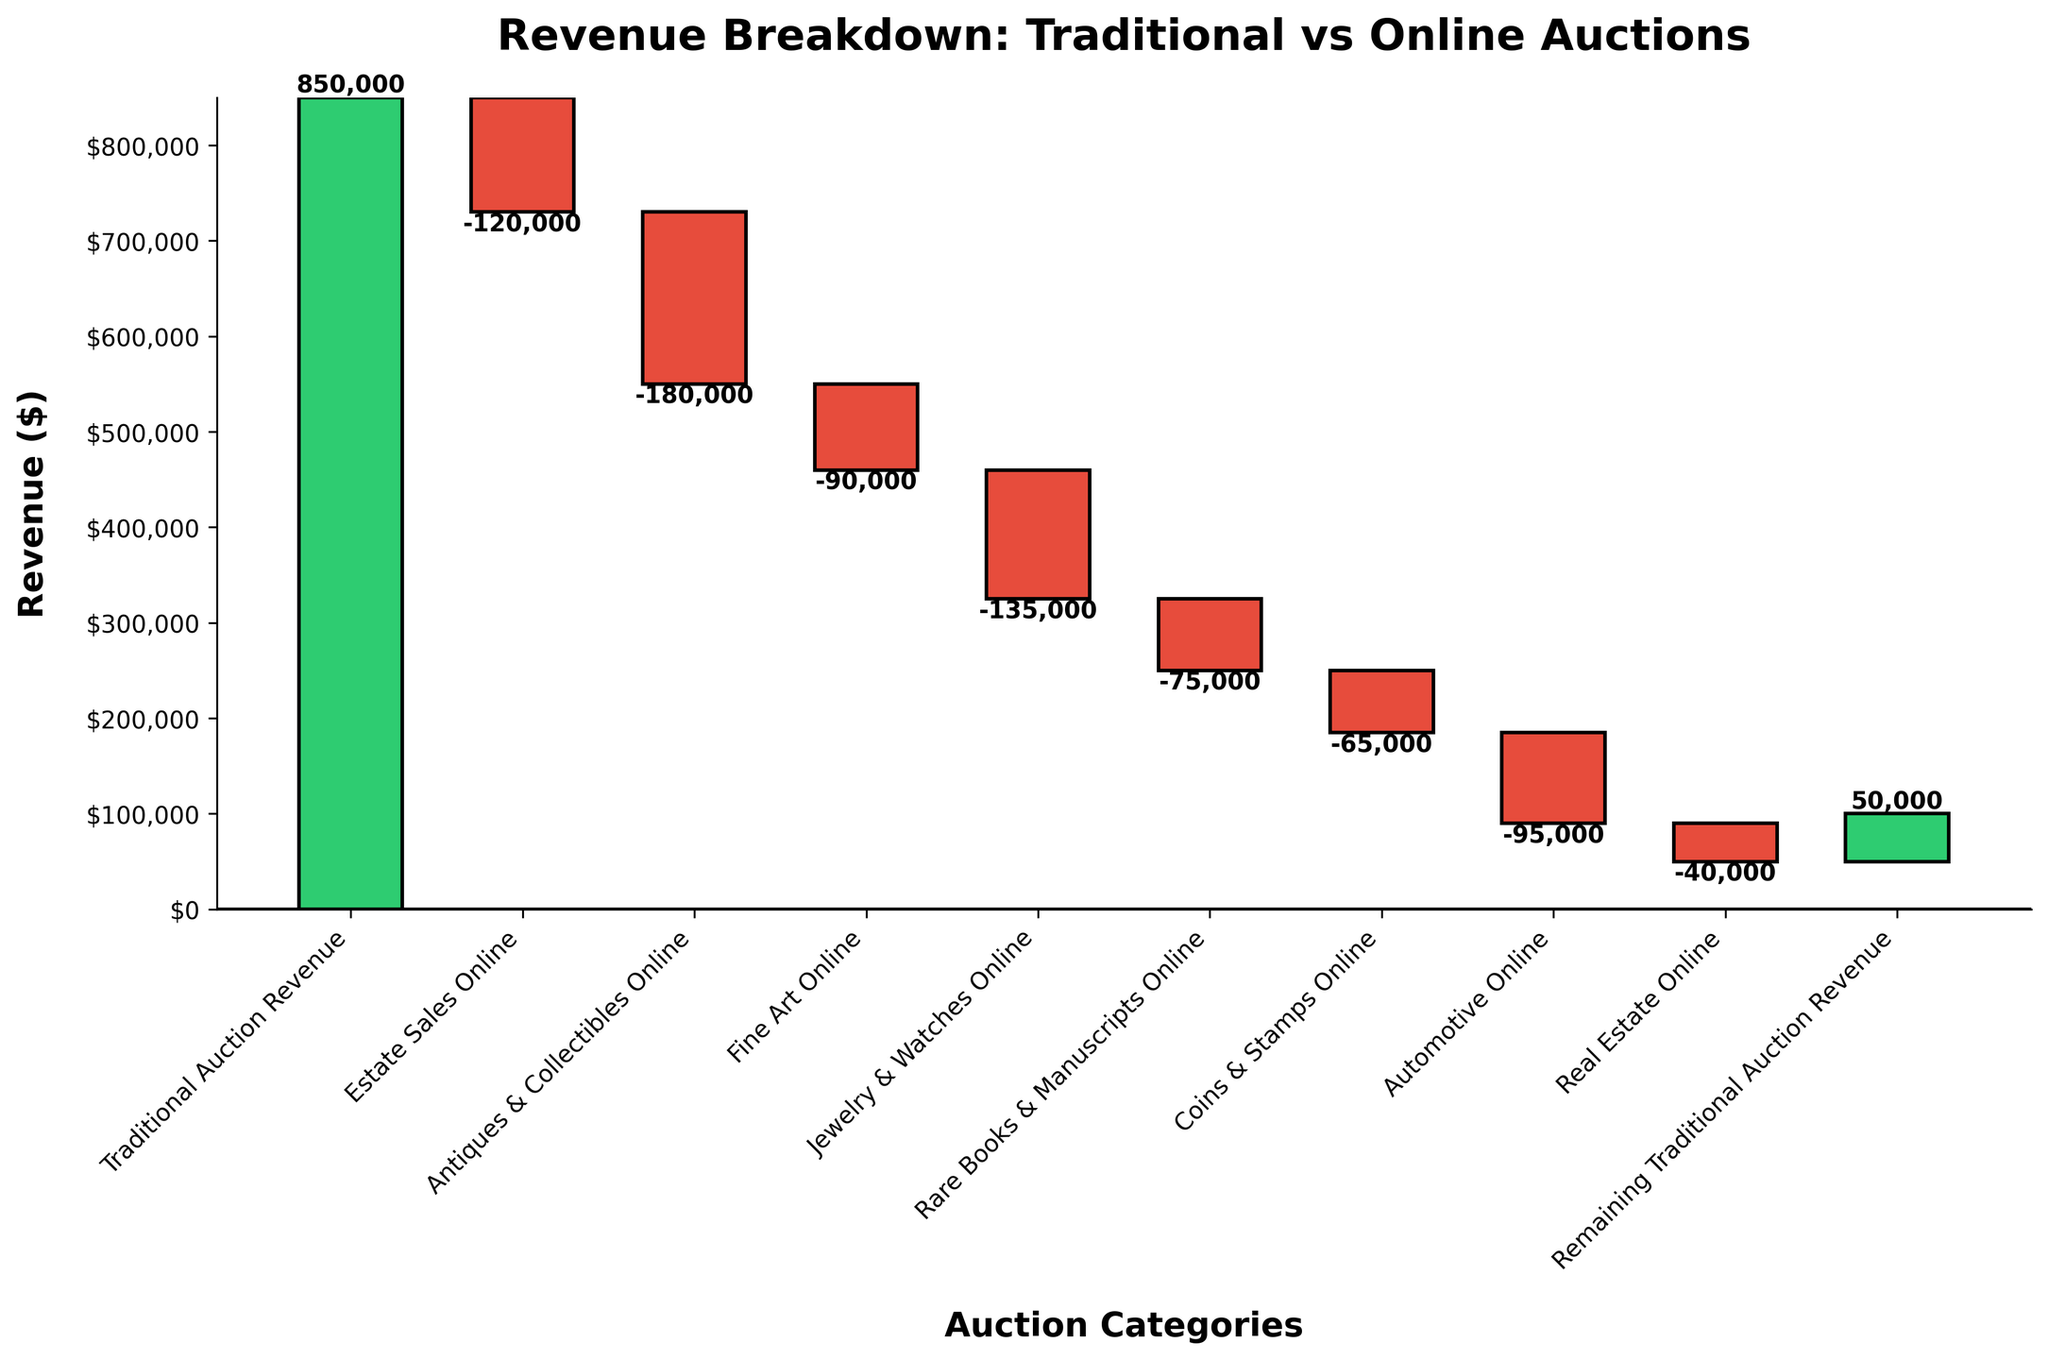What is the total revenue from Traditional Auction Revenue? The category "Traditional Auction Revenue" is directly labeled on the chart with the value $850,000
Answer: $850,000 How much revenue was lost from Estate Sales Online? The chart shows that "Estate Sales Online" contributed -$120,000 to the total revenue
Answer: -$120,000 Which category within Online Auctions had the smallest negative revenue? Among the categories within Online Auctions, "Real Estate Online" shows the smallest negative revenue with -$40,000
Answer: -$40,000 What is the combined negative revenue from Antiques & Collectibles Online and Jewelry & Watches Online categories? The negative revenues for "Antiques & Collectibles Online" and "Jewelry & Watches Online" are -$180,000 and -$135,000 respectively. Adding these together: -$180,000 + -$135,000 = -$315,000
Answer: -$315,000 What's the net revenue difference between Traditional Auction Revenue and all the Online categories? The Traditional Auction Revenue is $850,000. The sum of all losses from online categories can be calculated: -$120,000 + -$180,000 + -$90,000 + -$135,000 + -$75,000 + -$65,000 + -$95,000 + -$40,000 = -$800,000. The net difference: $850,000 - $800,000 = $50,000
Answer: $50,000 Which online category had the largest negative impact on the revenue? The category "Antiques & Collectibles Online" shows the largest negative revenue with -$180,000 in the chart
Answer: -$180,000 What is the final total revenue after accounting for all categories? Starting with the initial Traditional Auction Revenue of $850,000, then sequentially adding the values for each category listed (including negative contributions from online categories and the positive remaining revenue), the final total is displayed as $50,000
Answer: $50,000 How does the remaining traditional auction revenue affect the final total? The remaining traditional auction revenue adds $50,000 to the net total after accounting for all other categories
Answer: +$50,000 